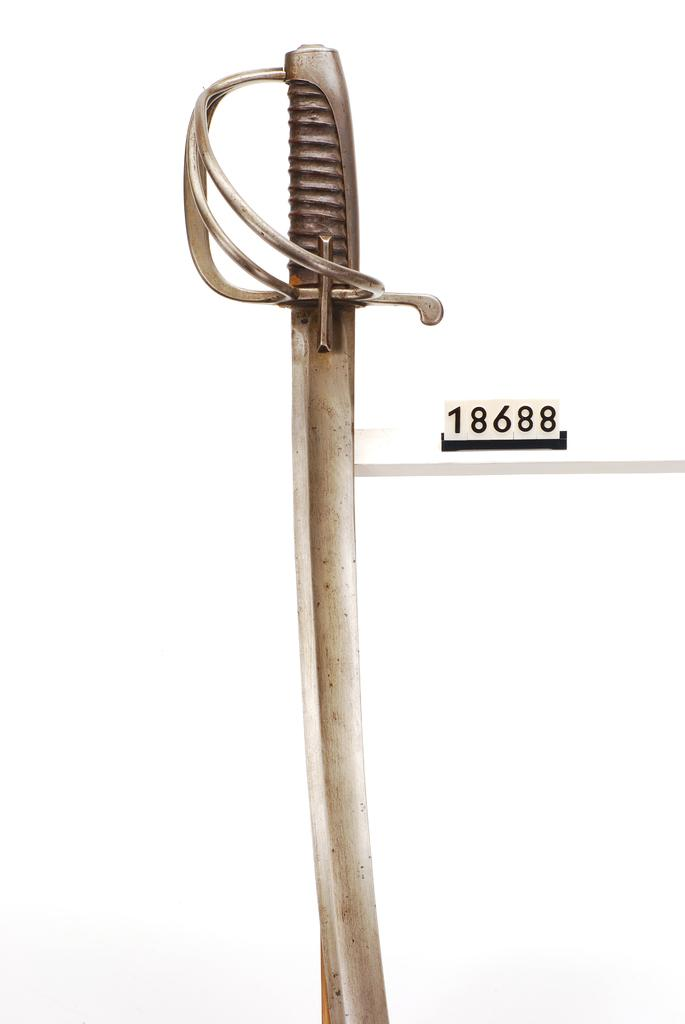What object can be seen in the image? There is a sword in the image. How many ducks are present in the image? There are no ducks present in the image; it only features a sword. Is there a tent visible in the image? No, there is no tent present in the image. 